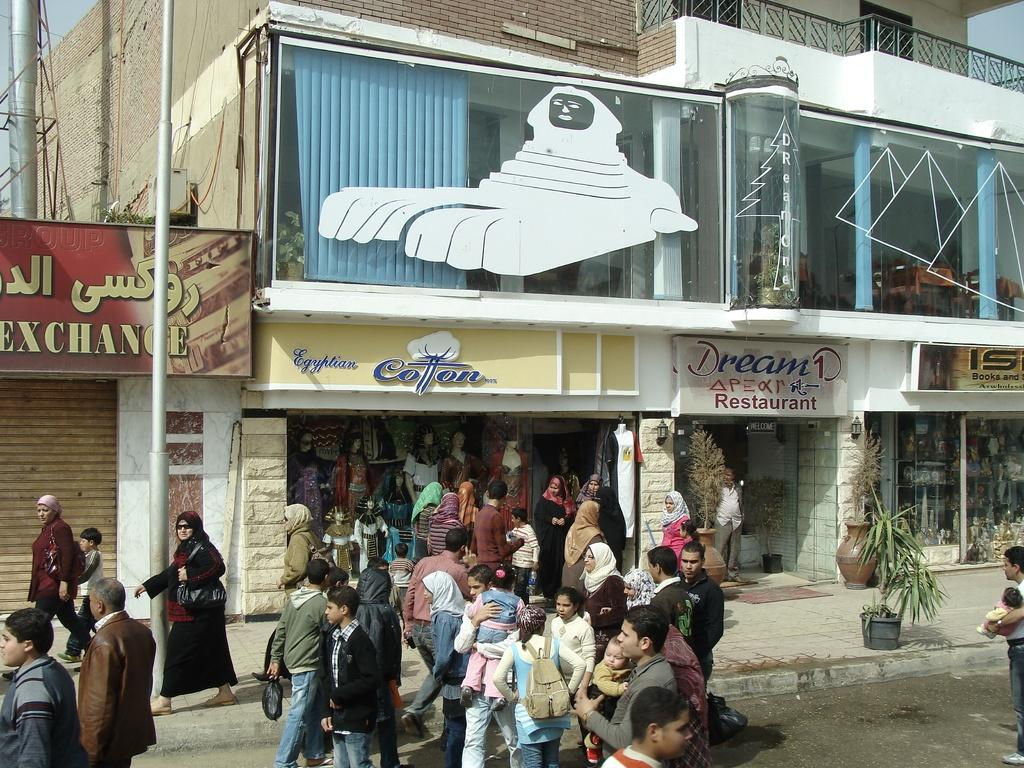What type of structures can be seen in the image? There are buildings in the image. What decorative elements are present in the image? There are banners in the image. What type of vegetation is visible in the image? There are plants in the image. What type of containers are present in the image? There are pots in the image. What type of vertical structure is present in the image? There is a pole in the image. Are there any living beings present in the image? Yes, there are people present in the image. What type of straw is being used by the people in the image? There is no straw present in the image. What type of street is visible in the image? There is no street visible in the image. 